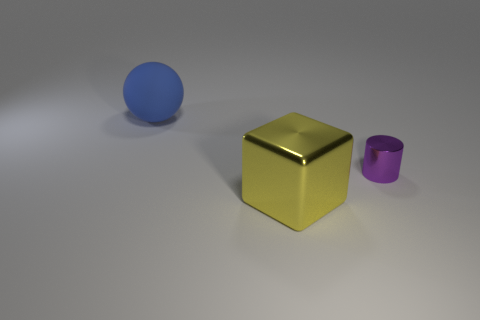Can you describe the arrangement and colors of the objects? Certainly! In the image, three distinct objects are presented against a neutral background. On the left, there's a large, matte blue sphere. Center stage, we see a reflective golden cube that commands attention. Finally, to the right, a tiny, matte purple cylinder rests unassumingly. The layout is simple, yet the contrast in colors and sizes creates an interesting visual composition. 